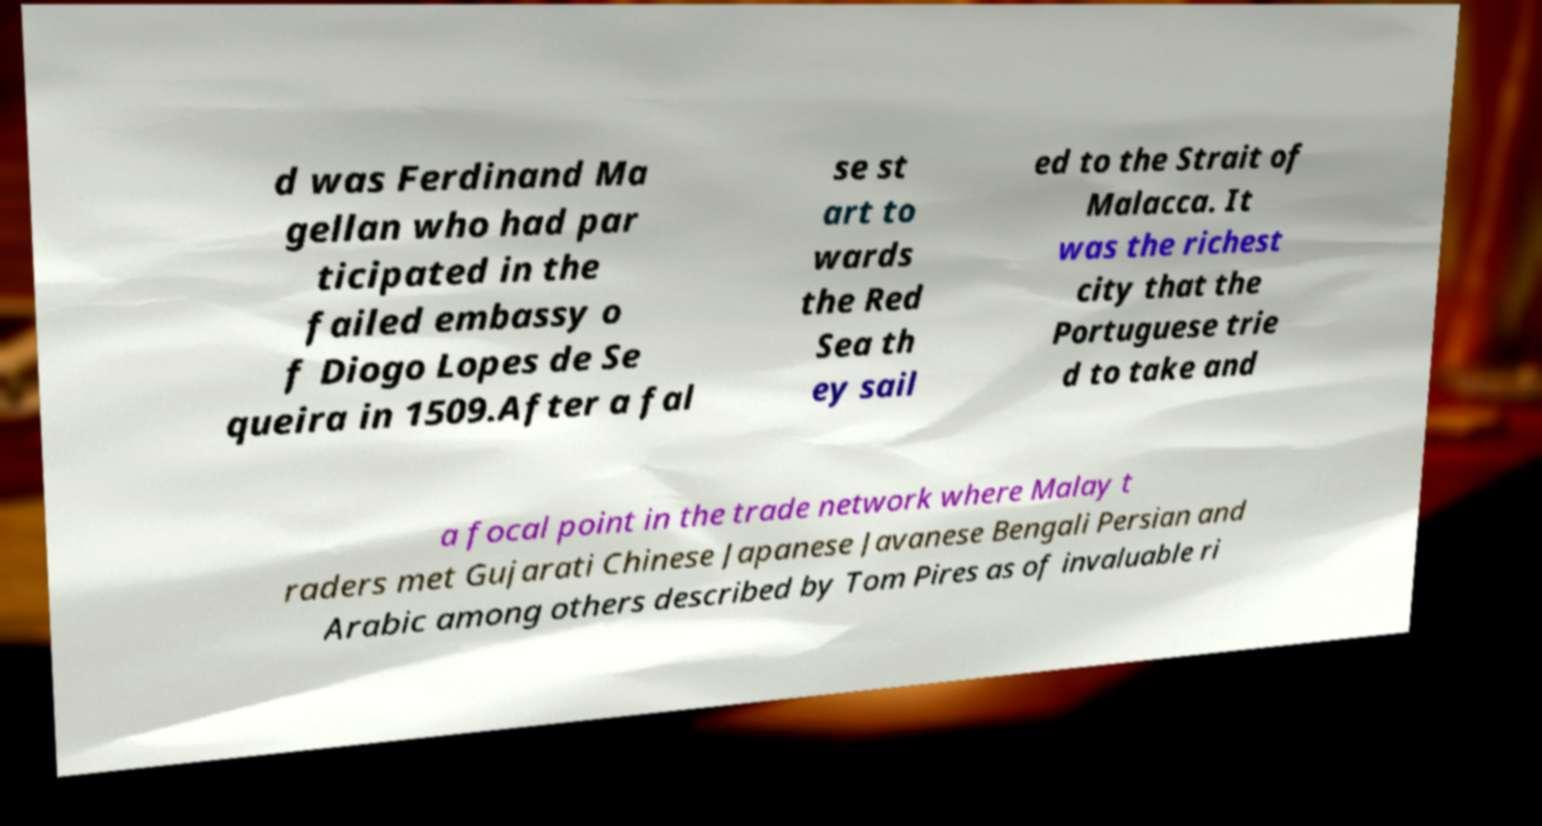Please read and relay the text visible in this image. What does it say? d was Ferdinand Ma gellan who had par ticipated in the failed embassy o f Diogo Lopes de Se queira in 1509.After a fal se st art to wards the Red Sea th ey sail ed to the Strait of Malacca. It was the richest city that the Portuguese trie d to take and a focal point in the trade network where Malay t raders met Gujarati Chinese Japanese Javanese Bengali Persian and Arabic among others described by Tom Pires as of invaluable ri 